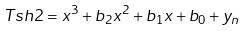Convert formula to latex. <formula><loc_0><loc_0><loc_500><loc_500>T s h 2 = x ^ { 3 } + b _ { 2 } x ^ { 2 } + b _ { 1 } x + b _ { 0 } + y _ { n }</formula> 